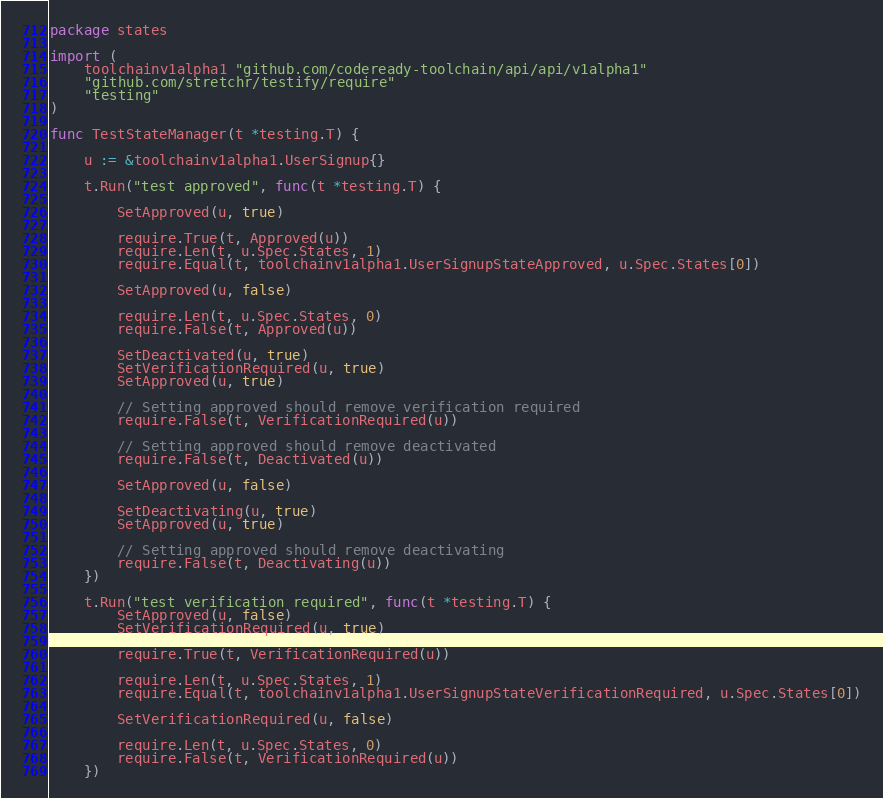Convert code to text. <code><loc_0><loc_0><loc_500><loc_500><_Go_>package states

import (
	toolchainv1alpha1 "github.com/codeready-toolchain/api/api/v1alpha1"
	"github.com/stretchr/testify/require"
	"testing"
)

func TestStateManager(t *testing.T) {

	u := &toolchainv1alpha1.UserSignup{}

	t.Run("test approved", func(t *testing.T) {

		SetApproved(u, true)

		require.True(t, Approved(u))
		require.Len(t, u.Spec.States, 1)
		require.Equal(t, toolchainv1alpha1.UserSignupStateApproved, u.Spec.States[0])

		SetApproved(u, false)

		require.Len(t, u.Spec.States, 0)
		require.False(t, Approved(u))

		SetDeactivated(u, true)
		SetVerificationRequired(u, true)
		SetApproved(u, true)

		// Setting approved should remove verification required
		require.False(t, VerificationRequired(u))

		// Setting approved should remove deactivated
		require.False(t, Deactivated(u))

		SetApproved(u, false)

		SetDeactivating(u, true)
		SetApproved(u, true)

		// Setting approved should remove deactivating
		require.False(t, Deactivating(u))
	})

	t.Run("test verification required", func(t *testing.T) {
		SetApproved(u, false)
		SetVerificationRequired(u, true)

		require.True(t, VerificationRequired(u))

		require.Len(t, u.Spec.States, 1)
		require.Equal(t, toolchainv1alpha1.UserSignupStateVerificationRequired, u.Spec.States[0])

		SetVerificationRequired(u, false)

		require.Len(t, u.Spec.States, 0)
		require.False(t, VerificationRequired(u))
	})
</code> 